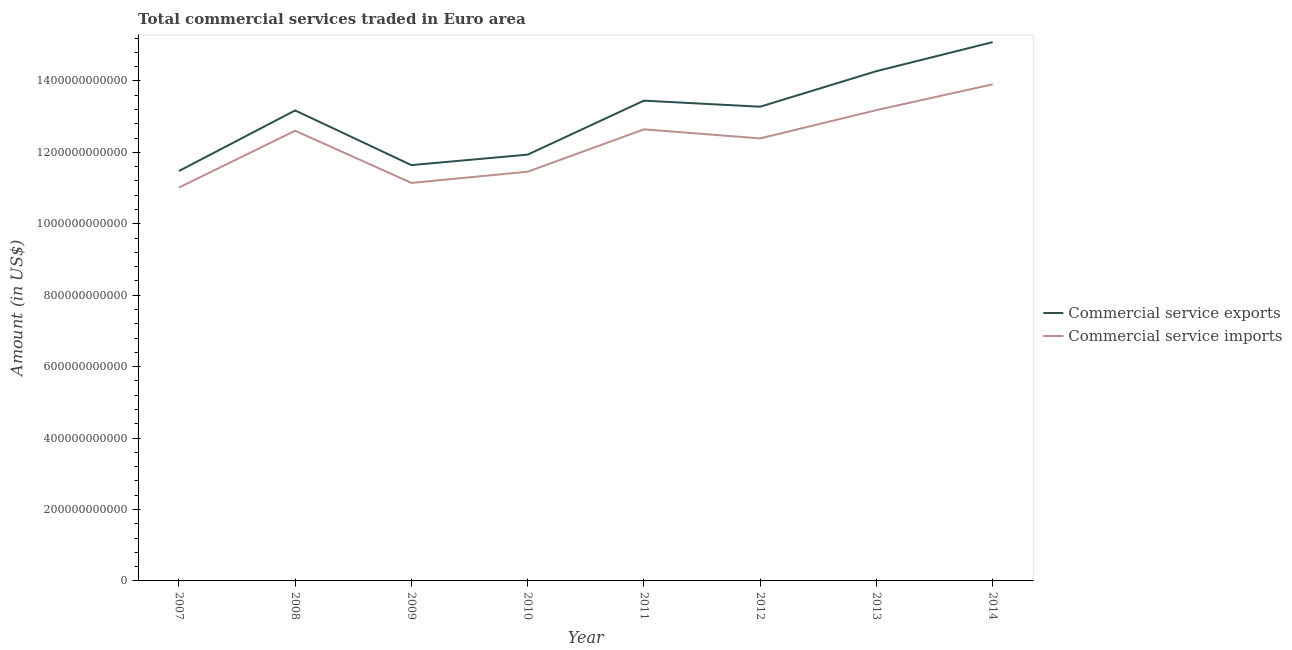What is the amount of commercial service imports in 2008?
Offer a terse response. 1.26e+12. Across all years, what is the maximum amount of commercial service exports?
Make the answer very short. 1.51e+12. Across all years, what is the minimum amount of commercial service imports?
Your answer should be compact. 1.10e+12. In which year was the amount of commercial service imports minimum?
Provide a short and direct response. 2007. What is the total amount of commercial service imports in the graph?
Your response must be concise. 9.84e+12. What is the difference between the amount of commercial service imports in 2007 and that in 2011?
Make the answer very short. -1.63e+11. What is the difference between the amount of commercial service exports in 2012 and the amount of commercial service imports in 2009?
Make the answer very short. 2.13e+11. What is the average amount of commercial service exports per year?
Your response must be concise. 1.30e+12. In the year 2014, what is the difference between the amount of commercial service exports and amount of commercial service imports?
Your answer should be compact. 1.18e+11. What is the ratio of the amount of commercial service imports in 2010 to that in 2012?
Ensure brevity in your answer.  0.92. Is the difference between the amount of commercial service imports in 2010 and 2012 greater than the difference between the amount of commercial service exports in 2010 and 2012?
Keep it short and to the point. Yes. What is the difference between the highest and the second highest amount of commercial service imports?
Make the answer very short. 7.23e+1. What is the difference between the highest and the lowest amount of commercial service imports?
Provide a succinct answer. 2.89e+11. In how many years, is the amount of commercial service exports greater than the average amount of commercial service exports taken over all years?
Provide a short and direct response. 5. Does the amount of commercial service imports monotonically increase over the years?
Provide a short and direct response. No. Is the amount of commercial service exports strictly greater than the amount of commercial service imports over the years?
Give a very brief answer. Yes. How many years are there in the graph?
Your answer should be compact. 8. What is the difference between two consecutive major ticks on the Y-axis?
Your response must be concise. 2.00e+11. Are the values on the major ticks of Y-axis written in scientific E-notation?
Keep it short and to the point. No. Where does the legend appear in the graph?
Ensure brevity in your answer.  Center right. How many legend labels are there?
Your answer should be very brief. 2. What is the title of the graph?
Your answer should be compact. Total commercial services traded in Euro area. Does "Infant" appear as one of the legend labels in the graph?
Make the answer very short. No. What is the label or title of the X-axis?
Give a very brief answer. Year. What is the label or title of the Y-axis?
Provide a short and direct response. Amount (in US$). What is the Amount (in US$) of Commercial service exports in 2007?
Your answer should be very brief. 1.15e+12. What is the Amount (in US$) in Commercial service imports in 2007?
Provide a short and direct response. 1.10e+12. What is the Amount (in US$) in Commercial service exports in 2008?
Offer a very short reply. 1.32e+12. What is the Amount (in US$) in Commercial service imports in 2008?
Make the answer very short. 1.26e+12. What is the Amount (in US$) in Commercial service exports in 2009?
Give a very brief answer. 1.16e+12. What is the Amount (in US$) of Commercial service imports in 2009?
Provide a short and direct response. 1.11e+12. What is the Amount (in US$) of Commercial service exports in 2010?
Keep it short and to the point. 1.19e+12. What is the Amount (in US$) of Commercial service imports in 2010?
Provide a succinct answer. 1.15e+12. What is the Amount (in US$) of Commercial service exports in 2011?
Your answer should be very brief. 1.34e+12. What is the Amount (in US$) of Commercial service imports in 2011?
Your response must be concise. 1.26e+12. What is the Amount (in US$) in Commercial service exports in 2012?
Ensure brevity in your answer.  1.33e+12. What is the Amount (in US$) of Commercial service imports in 2012?
Offer a terse response. 1.24e+12. What is the Amount (in US$) of Commercial service exports in 2013?
Offer a terse response. 1.43e+12. What is the Amount (in US$) in Commercial service imports in 2013?
Make the answer very short. 1.32e+12. What is the Amount (in US$) of Commercial service exports in 2014?
Provide a succinct answer. 1.51e+12. What is the Amount (in US$) of Commercial service imports in 2014?
Ensure brevity in your answer.  1.39e+12. Across all years, what is the maximum Amount (in US$) of Commercial service exports?
Provide a short and direct response. 1.51e+12. Across all years, what is the maximum Amount (in US$) of Commercial service imports?
Provide a succinct answer. 1.39e+12. Across all years, what is the minimum Amount (in US$) of Commercial service exports?
Your answer should be very brief. 1.15e+12. Across all years, what is the minimum Amount (in US$) of Commercial service imports?
Your answer should be very brief. 1.10e+12. What is the total Amount (in US$) in Commercial service exports in the graph?
Ensure brevity in your answer.  1.04e+13. What is the total Amount (in US$) of Commercial service imports in the graph?
Ensure brevity in your answer.  9.84e+12. What is the difference between the Amount (in US$) in Commercial service exports in 2007 and that in 2008?
Your answer should be compact. -1.70e+11. What is the difference between the Amount (in US$) of Commercial service imports in 2007 and that in 2008?
Your answer should be compact. -1.59e+11. What is the difference between the Amount (in US$) in Commercial service exports in 2007 and that in 2009?
Provide a succinct answer. -1.66e+1. What is the difference between the Amount (in US$) of Commercial service imports in 2007 and that in 2009?
Offer a terse response. -1.32e+1. What is the difference between the Amount (in US$) of Commercial service exports in 2007 and that in 2010?
Ensure brevity in your answer.  -4.59e+1. What is the difference between the Amount (in US$) of Commercial service imports in 2007 and that in 2010?
Make the answer very short. -4.45e+1. What is the difference between the Amount (in US$) in Commercial service exports in 2007 and that in 2011?
Make the answer very short. -1.97e+11. What is the difference between the Amount (in US$) in Commercial service imports in 2007 and that in 2011?
Your response must be concise. -1.63e+11. What is the difference between the Amount (in US$) of Commercial service exports in 2007 and that in 2012?
Your answer should be very brief. -1.80e+11. What is the difference between the Amount (in US$) in Commercial service imports in 2007 and that in 2012?
Your answer should be compact. -1.38e+11. What is the difference between the Amount (in US$) in Commercial service exports in 2007 and that in 2013?
Offer a terse response. -2.80e+11. What is the difference between the Amount (in US$) in Commercial service imports in 2007 and that in 2013?
Make the answer very short. -2.17e+11. What is the difference between the Amount (in US$) of Commercial service exports in 2007 and that in 2014?
Keep it short and to the point. -3.61e+11. What is the difference between the Amount (in US$) of Commercial service imports in 2007 and that in 2014?
Give a very brief answer. -2.89e+11. What is the difference between the Amount (in US$) in Commercial service exports in 2008 and that in 2009?
Your answer should be very brief. 1.53e+11. What is the difference between the Amount (in US$) in Commercial service imports in 2008 and that in 2009?
Offer a very short reply. 1.46e+11. What is the difference between the Amount (in US$) of Commercial service exports in 2008 and that in 2010?
Offer a very short reply. 1.24e+11. What is the difference between the Amount (in US$) of Commercial service imports in 2008 and that in 2010?
Make the answer very short. 1.15e+11. What is the difference between the Amount (in US$) in Commercial service exports in 2008 and that in 2011?
Ensure brevity in your answer.  -2.74e+1. What is the difference between the Amount (in US$) in Commercial service imports in 2008 and that in 2011?
Your response must be concise. -3.87e+09. What is the difference between the Amount (in US$) in Commercial service exports in 2008 and that in 2012?
Provide a short and direct response. -1.04e+1. What is the difference between the Amount (in US$) in Commercial service imports in 2008 and that in 2012?
Keep it short and to the point. 2.15e+1. What is the difference between the Amount (in US$) of Commercial service exports in 2008 and that in 2013?
Provide a succinct answer. -1.10e+11. What is the difference between the Amount (in US$) of Commercial service imports in 2008 and that in 2013?
Offer a very short reply. -5.77e+1. What is the difference between the Amount (in US$) of Commercial service exports in 2008 and that in 2014?
Provide a succinct answer. -1.91e+11. What is the difference between the Amount (in US$) in Commercial service imports in 2008 and that in 2014?
Your answer should be very brief. -1.30e+11. What is the difference between the Amount (in US$) in Commercial service exports in 2009 and that in 2010?
Provide a short and direct response. -2.93e+1. What is the difference between the Amount (in US$) of Commercial service imports in 2009 and that in 2010?
Offer a terse response. -3.13e+1. What is the difference between the Amount (in US$) of Commercial service exports in 2009 and that in 2011?
Keep it short and to the point. -1.81e+11. What is the difference between the Amount (in US$) in Commercial service imports in 2009 and that in 2011?
Provide a succinct answer. -1.50e+11. What is the difference between the Amount (in US$) of Commercial service exports in 2009 and that in 2012?
Provide a succinct answer. -1.64e+11. What is the difference between the Amount (in US$) in Commercial service imports in 2009 and that in 2012?
Make the answer very short. -1.25e+11. What is the difference between the Amount (in US$) of Commercial service exports in 2009 and that in 2013?
Ensure brevity in your answer.  -2.63e+11. What is the difference between the Amount (in US$) of Commercial service imports in 2009 and that in 2013?
Your answer should be very brief. -2.04e+11. What is the difference between the Amount (in US$) of Commercial service exports in 2009 and that in 2014?
Provide a short and direct response. -3.44e+11. What is the difference between the Amount (in US$) in Commercial service imports in 2009 and that in 2014?
Your answer should be very brief. -2.76e+11. What is the difference between the Amount (in US$) in Commercial service exports in 2010 and that in 2011?
Provide a succinct answer. -1.51e+11. What is the difference between the Amount (in US$) of Commercial service imports in 2010 and that in 2011?
Give a very brief answer. -1.19e+11. What is the difference between the Amount (in US$) of Commercial service exports in 2010 and that in 2012?
Provide a short and direct response. -1.34e+11. What is the difference between the Amount (in US$) of Commercial service imports in 2010 and that in 2012?
Provide a short and direct response. -9.33e+1. What is the difference between the Amount (in US$) in Commercial service exports in 2010 and that in 2013?
Offer a very short reply. -2.34e+11. What is the difference between the Amount (in US$) of Commercial service imports in 2010 and that in 2013?
Give a very brief answer. -1.72e+11. What is the difference between the Amount (in US$) in Commercial service exports in 2010 and that in 2014?
Provide a succinct answer. -3.15e+11. What is the difference between the Amount (in US$) in Commercial service imports in 2010 and that in 2014?
Offer a terse response. -2.45e+11. What is the difference between the Amount (in US$) of Commercial service exports in 2011 and that in 2012?
Provide a succinct answer. 1.70e+1. What is the difference between the Amount (in US$) of Commercial service imports in 2011 and that in 2012?
Your response must be concise. 2.53e+1. What is the difference between the Amount (in US$) in Commercial service exports in 2011 and that in 2013?
Your answer should be very brief. -8.26e+1. What is the difference between the Amount (in US$) of Commercial service imports in 2011 and that in 2013?
Make the answer very short. -5.38e+1. What is the difference between the Amount (in US$) of Commercial service exports in 2011 and that in 2014?
Give a very brief answer. -1.64e+11. What is the difference between the Amount (in US$) of Commercial service imports in 2011 and that in 2014?
Keep it short and to the point. -1.26e+11. What is the difference between the Amount (in US$) of Commercial service exports in 2012 and that in 2013?
Make the answer very short. -9.96e+1. What is the difference between the Amount (in US$) in Commercial service imports in 2012 and that in 2013?
Provide a succinct answer. -7.92e+1. What is the difference between the Amount (in US$) of Commercial service exports in 2012 and that in 2014?
Your answer should be very brief. -1.81e+11. What is the difference between the Amount (in US$) in Commercial service imports in 2012 and that in 2014?
Keep it short and to the point. -1.51e+11. What is the difference between the Amount (in US$) of Commercial service exports in 2013 and that in 2014?
Make the answer very short. -8.12e+1. What is the difference between the Amount (in US$) in Commercial service imports in 2013 and that in 2014?
Provide a succinct answer. -7.23e+1. What is the difference between the Amount (in US$) of Commercial service exports in 2007 and the Amount (in US$) of Commercial service imports in 2008?
Provide a short and direct response. -1.13e+11. What is the difference between the Amount (in US$) of Commercial service exports in 2007 and the Amount (in US$) of Commercial service imports in 2009?
Give a very brief answer. 3.32e+1. What is the difference between the Amount (in US$) of Commercial service exports in 2007 and the Amount (in US$) of Commercial service imports in 2010?
Offer a very short reply. 1.91e+09. What is the difference between the Amount (in US$) in Commercial service exports in 2007 and the Amount (in US$) in Commercial service imports in 2011?
Provide a short and direct response. -1.17e+11. What is the difference between the Amount (in US$) in Commercial service exports in 2007 and the Amount (in US$) in Commercial service imports in 2012?
Keep it short and to the point. -9.14e+1. What is the difference between the Amount (in US$) of Commercial service exports in 2007 and the Amount (in US$) of Commercial service imports in 2013?
Make the answer very short. -1.71e+11. What is the difference between the Amount (in US$) of Commercial service exports in 2007 and the Amount (in US$) of Commercial service imports in 2014?
Your answer should be compact. -2.43e+11. What is the difference between the Amount (in US$) in Commercial service exports in 2008 and the Amount (in US$) in Commercial service imports in 2009?
Offer a terse response. 2.03e+11. What is the difference between the Amount (in US$) in Commercial service exports in 2008 and the Amount (in US$) in Commercial service imports in 2010?
Offer a terse response. 1.72e+11. What is the difference between the Amount (in US$) of Commercial service exports in 2008 and the Amount (in US$) of Commercial service imports in 2011?
Ensure brevity in your answer.  5.30e+1. What is the difference between the Amount (in US$) in Commercial service exports in 2008 and the Amount (in US$) in Commercial service imports in 2012?
Your response must be concise. 7.83e+1. What is the difference between the Amount (in US$) of Commercial service exports in 2008 and the Amount (in US$) of Commercial service imports in 2013?
Your answer should be very brief. -8.59e+08. What is the difference between the Amount (in US$) in Commercial service exports in 2008 and the Amount (in US$) in Commercial service imports in 2014?
Your answer should be compact. -7.31e+1. What is the difference between the Amount (in US$) in Commercial service exports in 2009 and the Amount (in US$) in Commercial service imports in 2010?
Keep it short and to the point. 1.85e+1. What is the difference between the Amount (in US$) in Commercial service exports in 2009 and the Amount (in US$) in Commercial service imports in 2011?
Your response must be concise. -1.00e+11. What is the difference between the Amount (in US$) of Commercial service exports in 2009 and the Amount (in US$) of Commercial service imports in 2012?
Your response must be concise. -7.48e+1. What is the difference between the Amount (in US$) of Commercial service exports in 2009 and the Amount (in US$) of Commercial service imports in 2013?
Offer a very short reply. -1.54e+11. What is the difference between the Amount (in US$) of Commercial service exports in 2009 and the Amount (in US$) of Commercial service imports in 2014?
Offer a terse response. -2.26e+11. What is the difference between the Amount (in US$) of Commercial service exports in 2010 and the Amount (in US$) of Commercial service imports in 2011?
Your answer should be compact. -7.08e+1. What is the difference between the Amount (in US$) in Commercial service exports in 2010 and the Amount (in US$) in Commercial service imports in 2012?
Offer a terse response. -4.55e+1. What is the difference between the Amount (in US$) of Commercial service exports in 2010 and the Amount (in US$) of Commercial service imports in 2013?
Your response must be concise. -1.25e+11. What is the difference between the Amount (in US$) in Commercial service exports in 2010 and the Amount (in US$) in Commercial service imports in 2014?
Offer a very short reply. -1.97e+11. What is the difference between the Amount (in US$) of Commercial service exports in 2011 and the Amount (in US$) of Commercial service imports in 2012?
Your answer should be compact. 1.06e+11. What is the difference between the Amount (in US$) in Commercial service exports in 2011 and the Amount (in US$) in Commercial service imports in 2013?
Provide a succinct answer. 2.66e+1. What is the difference between the Amount (in US$) in Commercial service exports in 2011 and the Amount (in US$) in Commercial service imports in 2014?
Keep it short and to the point. -4.57e+1. What is the difference between the Amount (in US$) of Commercial service exports in 2012 and the Amount (in US$) of Commercial service imports in 2013?
Make the answer very short. 9.57e+09. What is the difference between the Amount (in US$) of Commercial service exports in 2012 and the Amount (in US$) of Commercial service imports in 2014?
Provide a succinct answer. -6.27e+1. What is the difference between the Amount (in US$) in Commercial service exports in 2013 and the Amount (in US$) in Commercial service imports in 2014?
Your answer should be compact. 3.69e+1. What is the average Amount (in US$) of Commercial service exports per year?
Provide a short and direct response. 1.30e+12. What is the average Amount (in US$) in Commercial service imports per year?
Make the answer very short. 1.23e+12. In the year 2007, what is the difference between the Amount (in US$) in Commercial service exports and Amount (in US$) in Commercial service imports?
Ensure brevity in your answer.  4.64e+1. In the year 2008, what is the difference between the Amount (in US$) in Commercial service exports and Amount (in US$) in Commercial service imports?
Provide a succinct answer. 5.69e+1. In the year 2009, what is the difference between the Amount (in US$) in Commercial service exports and Amount (in US$) in Commercial service imports?
Provide a short and direct response. 4.98e+1. In the year 2010, what is the difference between the Amount (in US$) in Commercial service exports and Amount (in US$) in Commercial service imports?
Offer a very short reply. 4.78e+1. In the year 2011, what is the difference between the Amount (in US$) in Commercial service exports and Amount (in US$) in Commercial service imports?
Your answer should be very brief. 8.04e+1. In the year 2012, what is the difference between the Amount (in US$) in Commercial service exports and Amount (in US$) in Commercial service imports?
Provide a succinct answer. 8.88e+1. In the year 2013, what is the difference between the Amount (in US$) of Commercial service exports and Amount (in US$) of Commercial service imports?
Provide a succinct answer. 1.09e+11. In the year 2014, what is the difference between the Amount (in US$) of Commercial service exports and Amount (in US$) of Commercial service imports?
Offer a terse response. 1.18e+11. What is the ratio of the Amount (in US$) in Commercial service exports in 2007 to that in 2008?
Offer a very short reply. 0.87. What is the ratio of the Amount (in US$) in Commercial service imports in 2007 to that in 2008?
Provide a short and direct response. 0.87. What is the ratio of the Amount (in US$) in Commercial service exports in 2007 to that in 2009?
Offer a terse response. 0.99. What is the ratio of the Amount (in US$) of Commercial service exports in 2007 to that in 2010?
Offer a very short reply. 0.96. What is the ratio of the Amount (in US$) of Commercial service imports in 2007 to that in 2010?
Make the answer very short. 0.96. What is the ratio of the Amount (in US$) of Commercial service exports in 2007 to that in 2011?
Keep it short and to the point. 0.85. What is the ratio of the Amount (in US$) in Commercial service imports in 2007 to that in 2011?
Offer a very short reply. 0.87. What is the ratio of the Amount (in US$) in Commercial service exports in 2007 to that in 2012?
Provide a succinct answer. 0.86. What is the ratio of the Amount (in US$) in Commercial service imports in 2007 to that in 2012?
Give a very brief answer. 0.89. What is the ratio of the Amount (in US$) of Commercial service exports in 2007 to that in 2013?
Your answer should be very brief. 0.8. What is the ratio of the Amount (in US$) of Commercial service imports in 2007 to that in 2013?
Ensure brevity in your answer.  0.84. What is the ratio of the Amount (in US$) of Commercial service exports in 2007 to that in 2014?
Provide a succinct answer. 0.76. What is the ratio of the Amount (in US$) of Commercial service imports in 2007 to that in 2014?
Give a very brief answer. 0.79. What is the ratio of the Amount (in US$) of Commercial service exports in 2008 to that in 2009?
Your answer should be very brief. 1.13. What is the ratio of the Amount (in US$) in Commercial service imports in 2008 to that in 2009?
Offer a very short reply. 1.13. What is the ratio of the Amount (in US$) in Commercial service exports in 2008 to that in 2010?
Offer a very short reply. 1.1. What is the ratio of the Amount (in US$) of Commercial service imports in 2008 to that in 2010?
Your response must be concise. 1.1. What is the ratio of the Amount (in US$) in Commercial service exports in 2008 to that in 2011?
Your response must be concise. 0.98. What is the ratio of the Amount (in US$) in Commercial service exports in 2008 to that in 2012?
Your response must be concise. 0.99. What is the ratio of the Amount (in US$) of Commercial service imports in 2008 to that in 2012?
Your answer should be compact. 1.02. What is the ratio of the Amount (in US$) of Commercial service exports in 2008 to that in 2013?
Keep it short and to the point. 0.92. What is the ratio of the Amount (in US$) of Commercial service imports in 2008 to that in 2013?
Provide a short and direct response. 0.96. What is the ratio of the Amount (in US$) in Commercial service exports in 2008 to that in 2014?
Your response must be concise. 0.87. What is the ratio of the Amount (in US$) in Commercial service imports in 2008 to that in 2014?
Your response must be concise. 0.91. What is the ratio of the Amount (in US$) of Commercial service exports in 2009 to that in 2010?
Keep it short and to the point. 0.98. What is the ratio of the Amount (in US$) in Commercial service imports in 2009 to that in 2010?
Your response must be concise. 0.97. What is the ratio of the Amount (in US$) of Commercial service exports in 2009 to that in 2011?
Provide a succinct answer. 0.87. What is the ratio of the Amount (in US$) of Commercial service imports in 2009 to that in 2011?
Your response must be concise. 0.88. What is the ratio of the Amount (in US$) in Commercial service exports in 2009 to that in 2012?
Ensure brevity in your answer.  0.88. What is the ratio of the Amount (in US$) of Commercial service imports in 2009 to that in 2012?
Keep it short and to the point. 0.9. What is the ratio of the Amount (in US$) of Commercial service exports in 2009 to that in 2013?
Your answer should be very brief. 0.82. What is the ratio of the Amount (in US$) of Commercial service imports in 2009 to that in 2013?
Offer a very short reply. 0.85. What is the ratio of the Amount (in US$) in Commercial service exports in 2009 to that in 2014?
Provide a succinct answer. 0.77. What is the ratio of the Amount (in US$) in Commercial service imports in 2009 to that in 2014?
Your response must be concise. 0.8. What is the ratio of the Amount (in US$) of Commercial service exports in 2010 to that in 2011?
Offer a terse response. 0.89. What is the ratio of the Amount (in US$) in Commercial service imports in 2010 to that in 2011?
Keep it short and to the point. 0.91. What is the ratio of the Amount (in US$) in Commercial service exports in 2010 to that in 2012?
Your response must be concise. 0.9. What is the ratio of the Amount (in US$) in Commercial service imports in 2010 to that in 2012?
Your answer should be compact. 0.92. What is the ratio of the Amount (in US$) in Commercial service exports in 2010 to that in 2013?
Offer a terse response. 0.84. What is the ratio of the Amount (in US$) of Commercial service imports in 2010 to that in 2013?
Your answer should be compact. 0.87. What is the ratio of the Amount (in US$) of Commercial service exports in 2010 to that in 2014?
Make the answer very short. 0.79. What is the ratio of the Amount (in US$) in Commercial service imports in 2010 to that in 2014?
Your response must be concise. 0.82. What is the ratio of the Amount (in US$) in Commercial service exports in 2011 to that in 2012?
Ensure brevity in your answer.  1.01. What is the ratio of the Amount (in US$) in Commercial service imports in 2011 to that in 2012?
Make the answer very short. 1.02. What is the ratio of the Amount (in US$) of Commercial service exports in 2011 to that in 2013?
Keep it short and to the point. 0.94. What is the ratio of the Amount (in US$) of Commercial service imports in 2011 to that in 2013?
Ensure brevity in your answer.  0.96. What is the ratio of the Amount (in US$) in Commercial service exports in 2011 to that in 2014?
Keep it short and to the point. 0.89. What is the ratio of the Amount (in US$) of Commercial service imports in 2011 to that in 2014?
Keep it short and to the point. 0.91. What is the ratio of the Amount (in US$) of Commercial service exports in 2012 to that in 2013?
Offer a terse response. 0.93. What is the ratio of the Amount (in US$) of Commercial service imports in 2012 to that in 2013?
Provide a succinct answer. 0.94. What is the ratio of the Amount (in US$) in Commercial service exports in 2012 to that in 2014?
Ensure brevity in your answer.  0.88. What is the ratio of the Amount (in US$) of Commercial service imports in 2012 to that in 2014?
Your answer should be very brief. 0.89. What is the ratio of the Amount (in US$) in Commercial service exports in 2013 to that in 2014?
Provide a succinct answer. 0.95. What is the ratio of the Amount (in US$) in Commercial service imports in 2013 to that in 2014?
Provide a succinct answer. 0.95. What is the difference between the highest and the second highest Amount (in US$) in Commercial service exports?
Offer a very short reply. 8.12e+1. What is the difference between the highest and the second highest Amount (in US$) in Commercial service imports?
Give a very brief answer. 7.23e+1. What is the difference between the highest and the lowest Amount (in US$) in Commercial service exports?
Your answer should be very brief. 3.61e+11. What is the difference between the highest and the lowest Amount (in US$) of Commercial service imports?
Your response must be concise. 2.89e+11. 